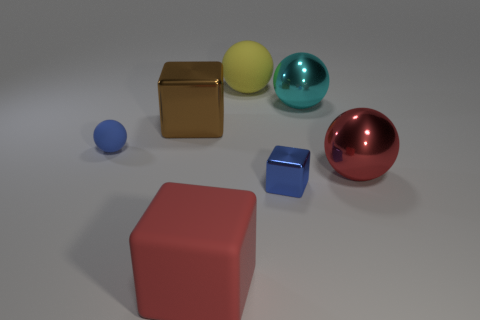There is a brown object that is the same size as the rubber block; what shape is it?
Ensure brevity in your answer.  Cube. How many big objects are both right of the big matte block and in front of the big red metal thing?
Provide a short and direct response. 0. Is the number of big matte blocks that are left of the big metallic cube less than the number of cyan things?
Give a very brief answer. Yes. Are there any yellow rubber objects of the same size as the yellow sphere?
Offer a very short reply. No. What is the color of the other sphere that is the same material as the small blue sphere?
Your response must be concise. Yellow. There is a small blue object that is left of the brown shiny object; what number of small objects are right of it?
Offer a very short reply. 1. What material is the ball that is to the right of the brown metallic object and in front of the cyan metallic thing?
Offer a very short reply. Metal. There is a small blue thing that is behind the blue metal block; does it have the same shape as the red shiny object?
Make the answer very short. Yes. Are there fewer big blue matte cylinders than large balls?
Offer a terse response. Yes. How many shiny spheres have the same color as the tiny cube?
Give a very brief answer. 0. 